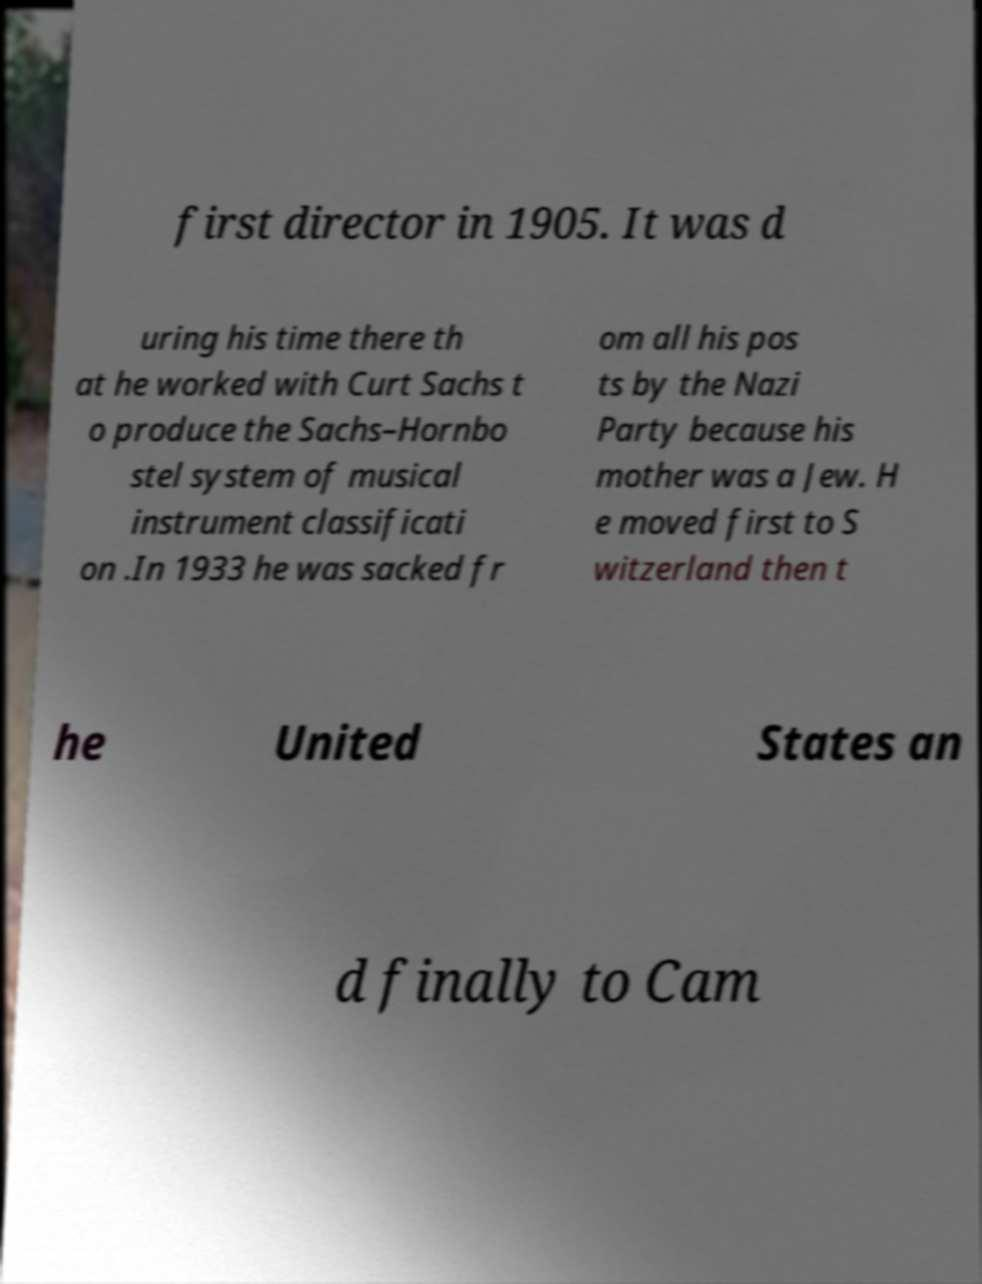I need the written content from this picture converted into text. Can you do that? first director in 1905. It was d uring his time there th at he worked with Curt Sachs t o produce the Sachs–Hornbo stel system of musical instrument classificati on .In 1933 he was sacked fr om all his pos ts by the Nazi Party because his mother was a Jew. H e moved first to S witzerland then t he United States an d finally to Cam 